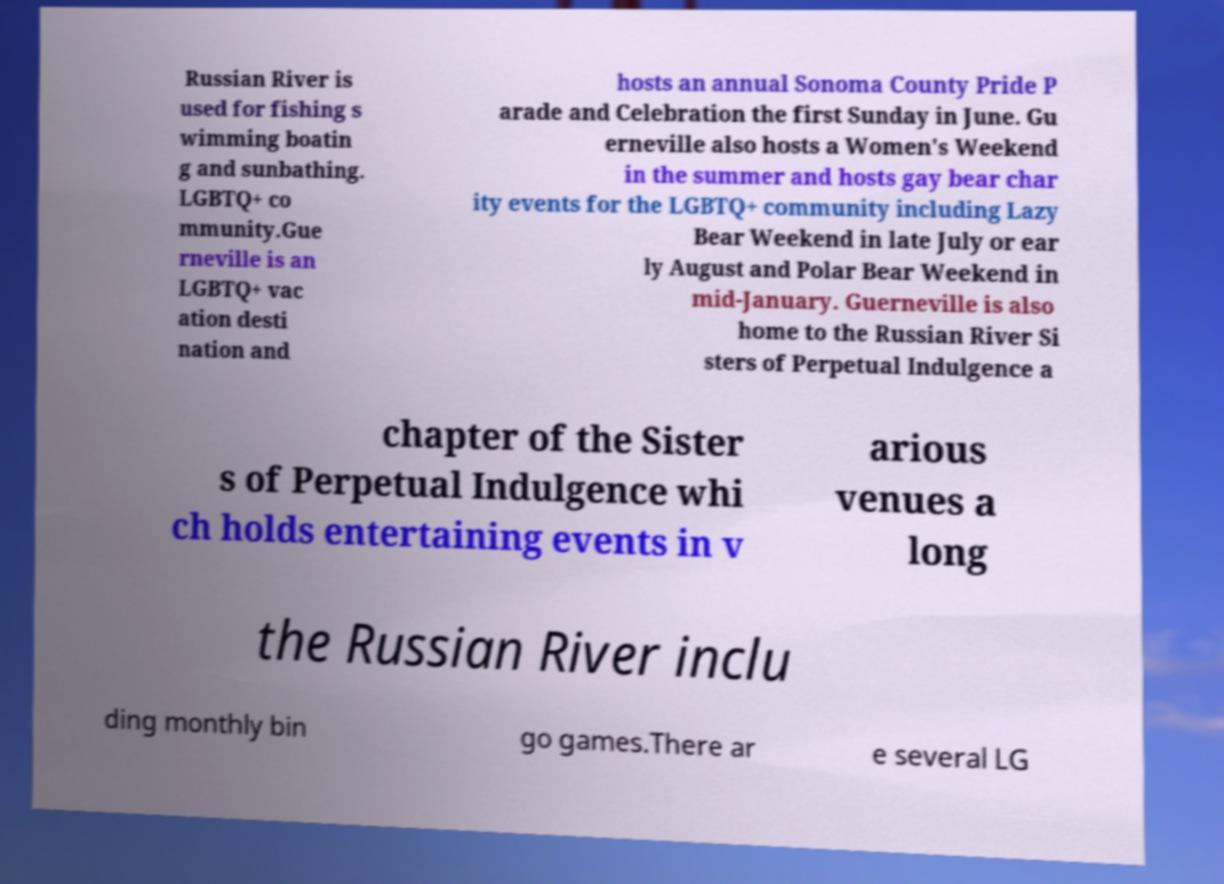What messages or text are displayed in this image? I need them in a readable, typed format. Russian River is used for fishing s wimming boatin g and sunbathing. LGBTQ+ co mmunity.Gue rneville is an LGBTQ+ vac ation desti nation and hosts an annual Sonoma County Pride P arade and Celebration the first Sunday in June. Gu erneville also hosts a Women's Weekend in the summer and hosts gay bear char ity events for the LGBTQ+ community including Lazy Bear Weekend in late July or ear ly August and Polar Bear Weekend in mid-January. Guerneville is also home to the Russian River Si sters of Perpetual Indulgence a chapter of the Sister s of Perpetual Indulgence whi ch holds entertaining events in v arious venues a long the Russian River inclu ding monthly bin go games.There ar e several LG 